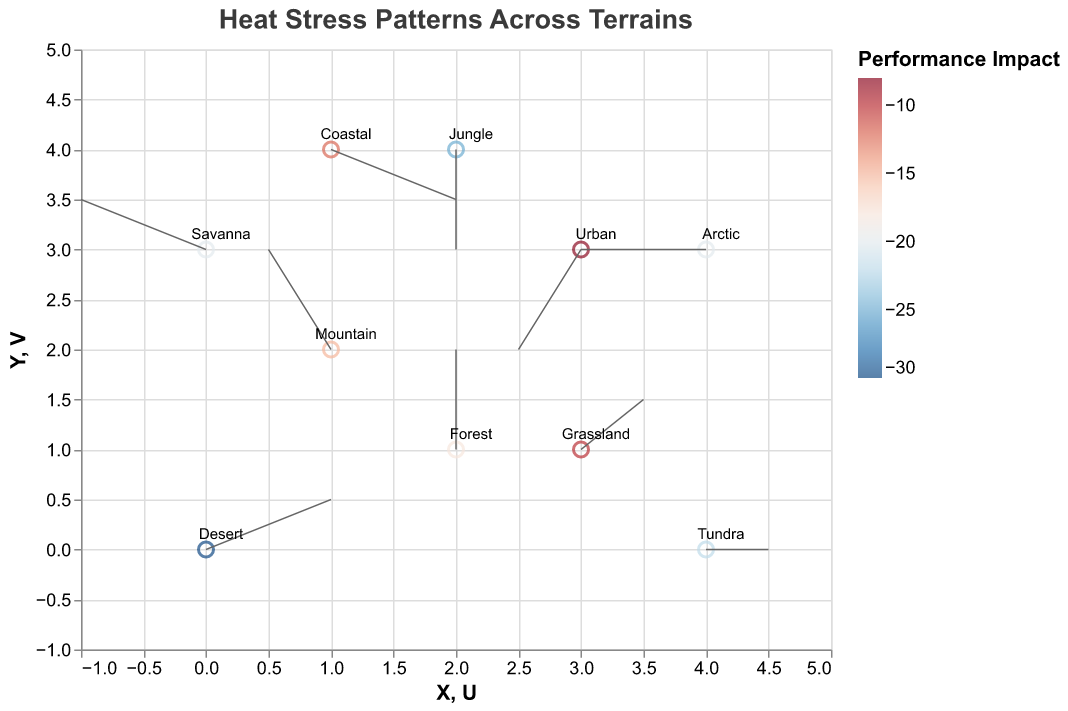What is the title of the figure? The title is displayed at the top of the figure.
Answer: Heat Stress Patterns Across Terrains What color represents the highest performance impact? The color representing the highest performance impact can be observed in the color legend and the points with the most intense color.
Answer: Dark Blue Which terrain shows the highest negative performance impact? By looking at the data points and their colors, the terrain with the darkest red color represents the highest negative performance impact.
Answer: Desert What is the performance impact in the forest terrain? Look at the point labeled "Forest" and check its color against the legend to identify its performance impact.
Answer: -18 How many data points are there in the figure? Count all the points by visually scanning the figure.
Answer: 10 Which terrain has the highest temperature and what is it? Identify the terrain point with the highest temperature by comparing the temperatures provided in the tooltips or directly in the legend.
Answer: Desert, 45 What is the relationship between temperature and performance impact across terrains? Compare the temperature and performance impact values for all terrains and observe any correlation between them, noting whether higher or lower temperatures tend to coincide with specific performance impacts.
Answer: Higher temperatures generally correlate with higher negative performance impacts Between which two terrains do we observe the biggest change in performance impact? Compare the performance impact values of all terrains and identify the pair with the greatest difference.
Answer: Desert and Urban What is the average temperature of all terrains? Sum all temperatures and divide by the number of data points: (45 + 25 + 35 + 30 - 20 + 28 + 33 + 27 + 5 + 38) / 10
Answer: 24.6 How does the performance impact vary with changes in terrain (wind direction and speed)? Observing the direction and length of the arrows (U and V components) in relation to the color of the points indicates how changes in position (terrain) relate to performance impact.
Answer: Varies with terrain, but no clear pattern from wind direction 